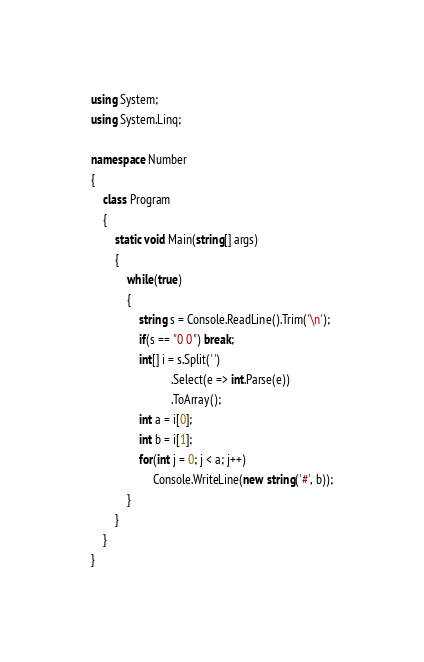Convert code to text. <code><loc_0><loc_0><loc_500><loc_500><_C#_>using System;
using System.Linq;

namespace Number
{
    class Program
    {
        static void Main(string[] args)
        {
            while(true)
            {
                string s = Console.ReadLine().Trim('\n');
                if(s == "0 0") break;
                int[] i = s.Split(' ')
                           .Select(e => int.Parse(e))
                           .ToArray();
                int a = i[0];
                int b = i[1];
                for(int j = 0; j < a; j++)
                     Console.WriteLine(new string('#', b));
            }
        }
    }
}</code> 